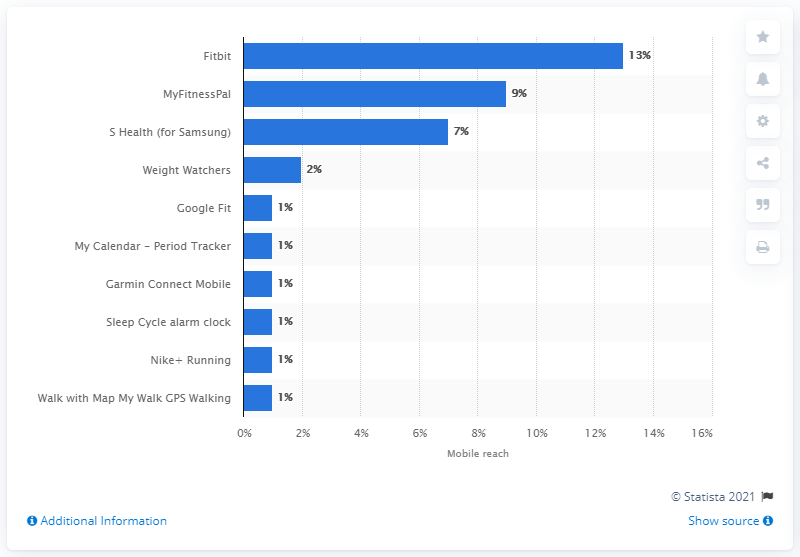Point out several critical features in this image. According to the information provided, the third most popular fitness app is MyFitnessPal, with a mobile penetration rate of 9 percent in the country where the information was gathered. 